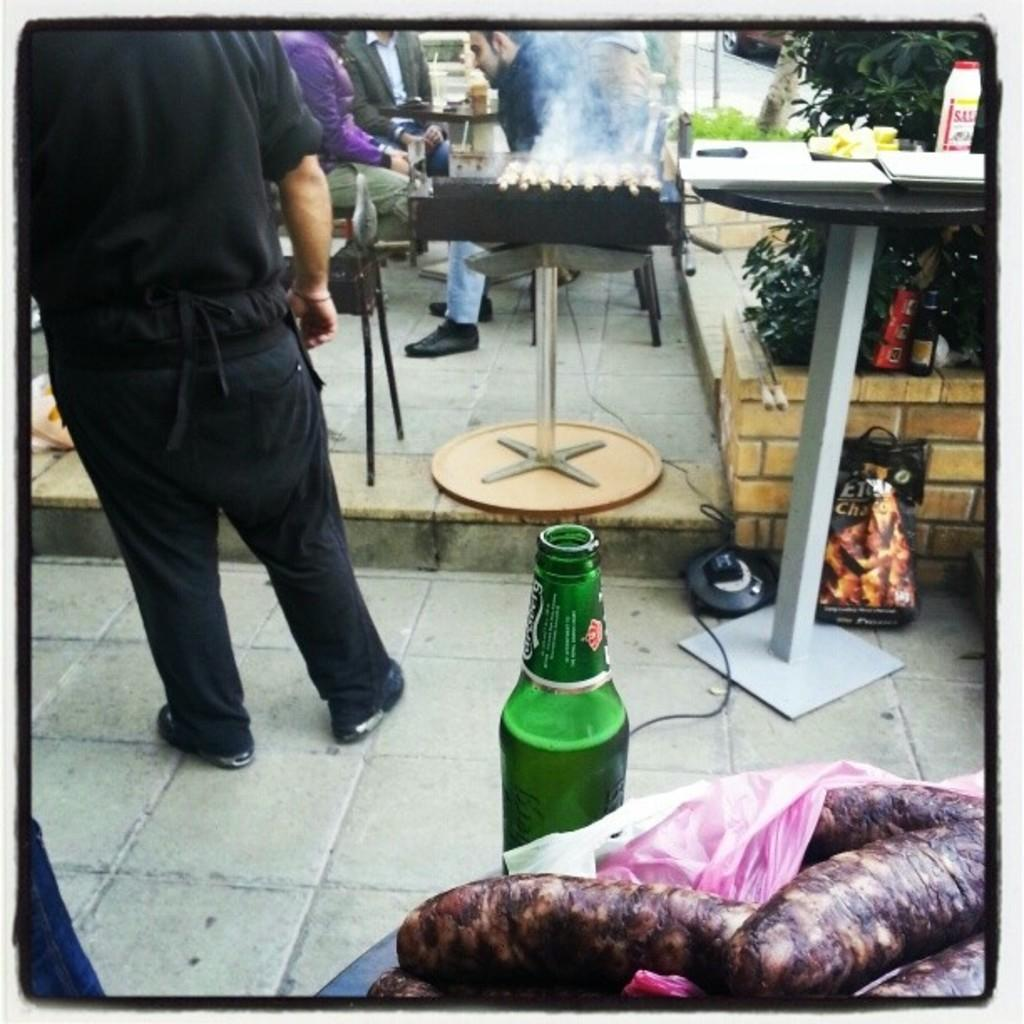What can be seen in the background of the image? There is a man standing in the background of the image. What is on the table in the image? There are papers on a table in the image. What object is present that might contain a liquid? There is a bottle in the image. What type of living organism is visible in the image? There is a plant in the image. How does the plant increase its trade with the mailbox in the image? There is no mailbox or trade activity involving the plant in the image. 